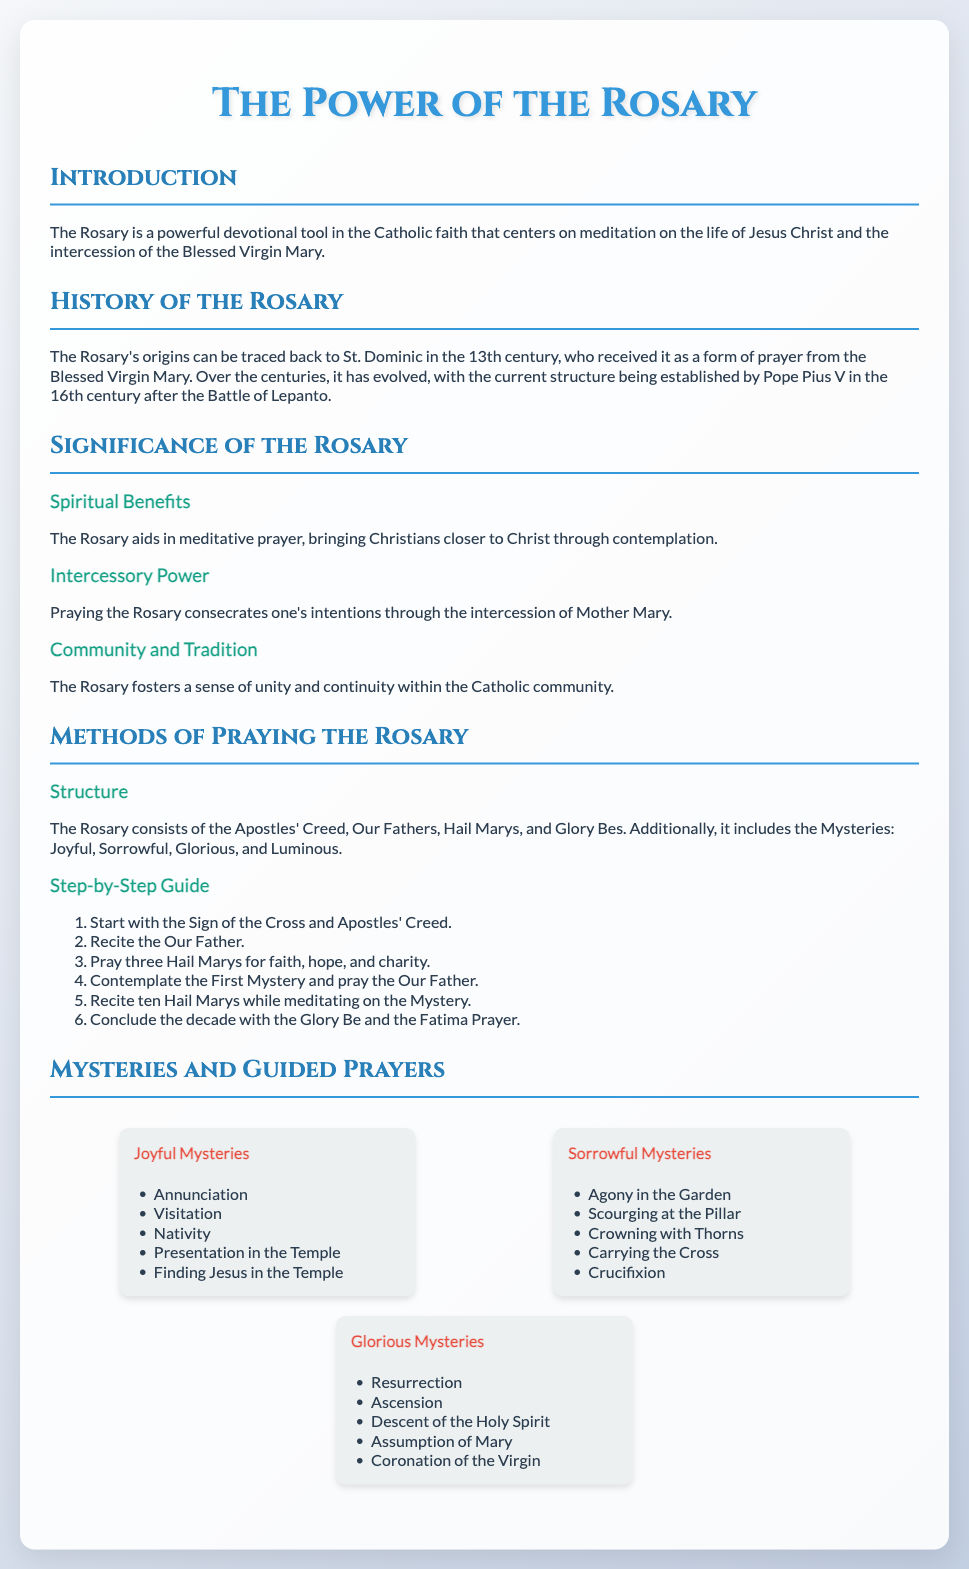What is the primary focus of the Rosary? The Rosary is a powerful devotional tool in the Catholic faith that centers on meditation on the life of Jesus Christ and the intercession of the Blessed Virgin Mary.
Answer: Meditation on Jesus and Mary Who is credited with the origin of the Rosary? The Rosary's origins can be traced back to St. Dominic in the 13th century.
Answer: St. Dominic What are the four types of Mysteries in the Rosary? The types of Mysteries are Joyful, Sorrowful, Glorious, and Luminous.
Answer: Joyful, Sorrowful, Glorious, Luminous In which century was the structure of the Rosary established? The current structure of the Rosary was established by Pope Pius V in the 16th century.
Answer: 16th century What type of prayer is primarily used in the Rosary? The Rosary consists of the Apostles' Creed, Our Fathers, Hail Marys, and Glory Bes.
Answer: Hail Marys What is one of the spiritual benefits of praying the Rosary? The Rosary aids in meditative prayer, bringing Christians closer to Christ through contemplation.
Answer: Meditative prayer How many Hail Marys are recited after contemplating the first mystery? Ten Hail Marys are recited while meditating on the Mystery.
Answer: Ten Hail Marys What prayer concludes each decade of the Rosary? Each decade is concluded with the Glory Be and the Fatima Prayer.
Answer: Glory Be and the Fatima Prayer What do the Joyful Mysteries include? The Joyful Mysteries include Annunciation, Visitation, Nativity, Presentation in the Temple, and Finding Jesus in the Temple.
Answer: Annunciation, Visitation, Nativity, Presentation in the Temple, Finding Jesus in the Temple 